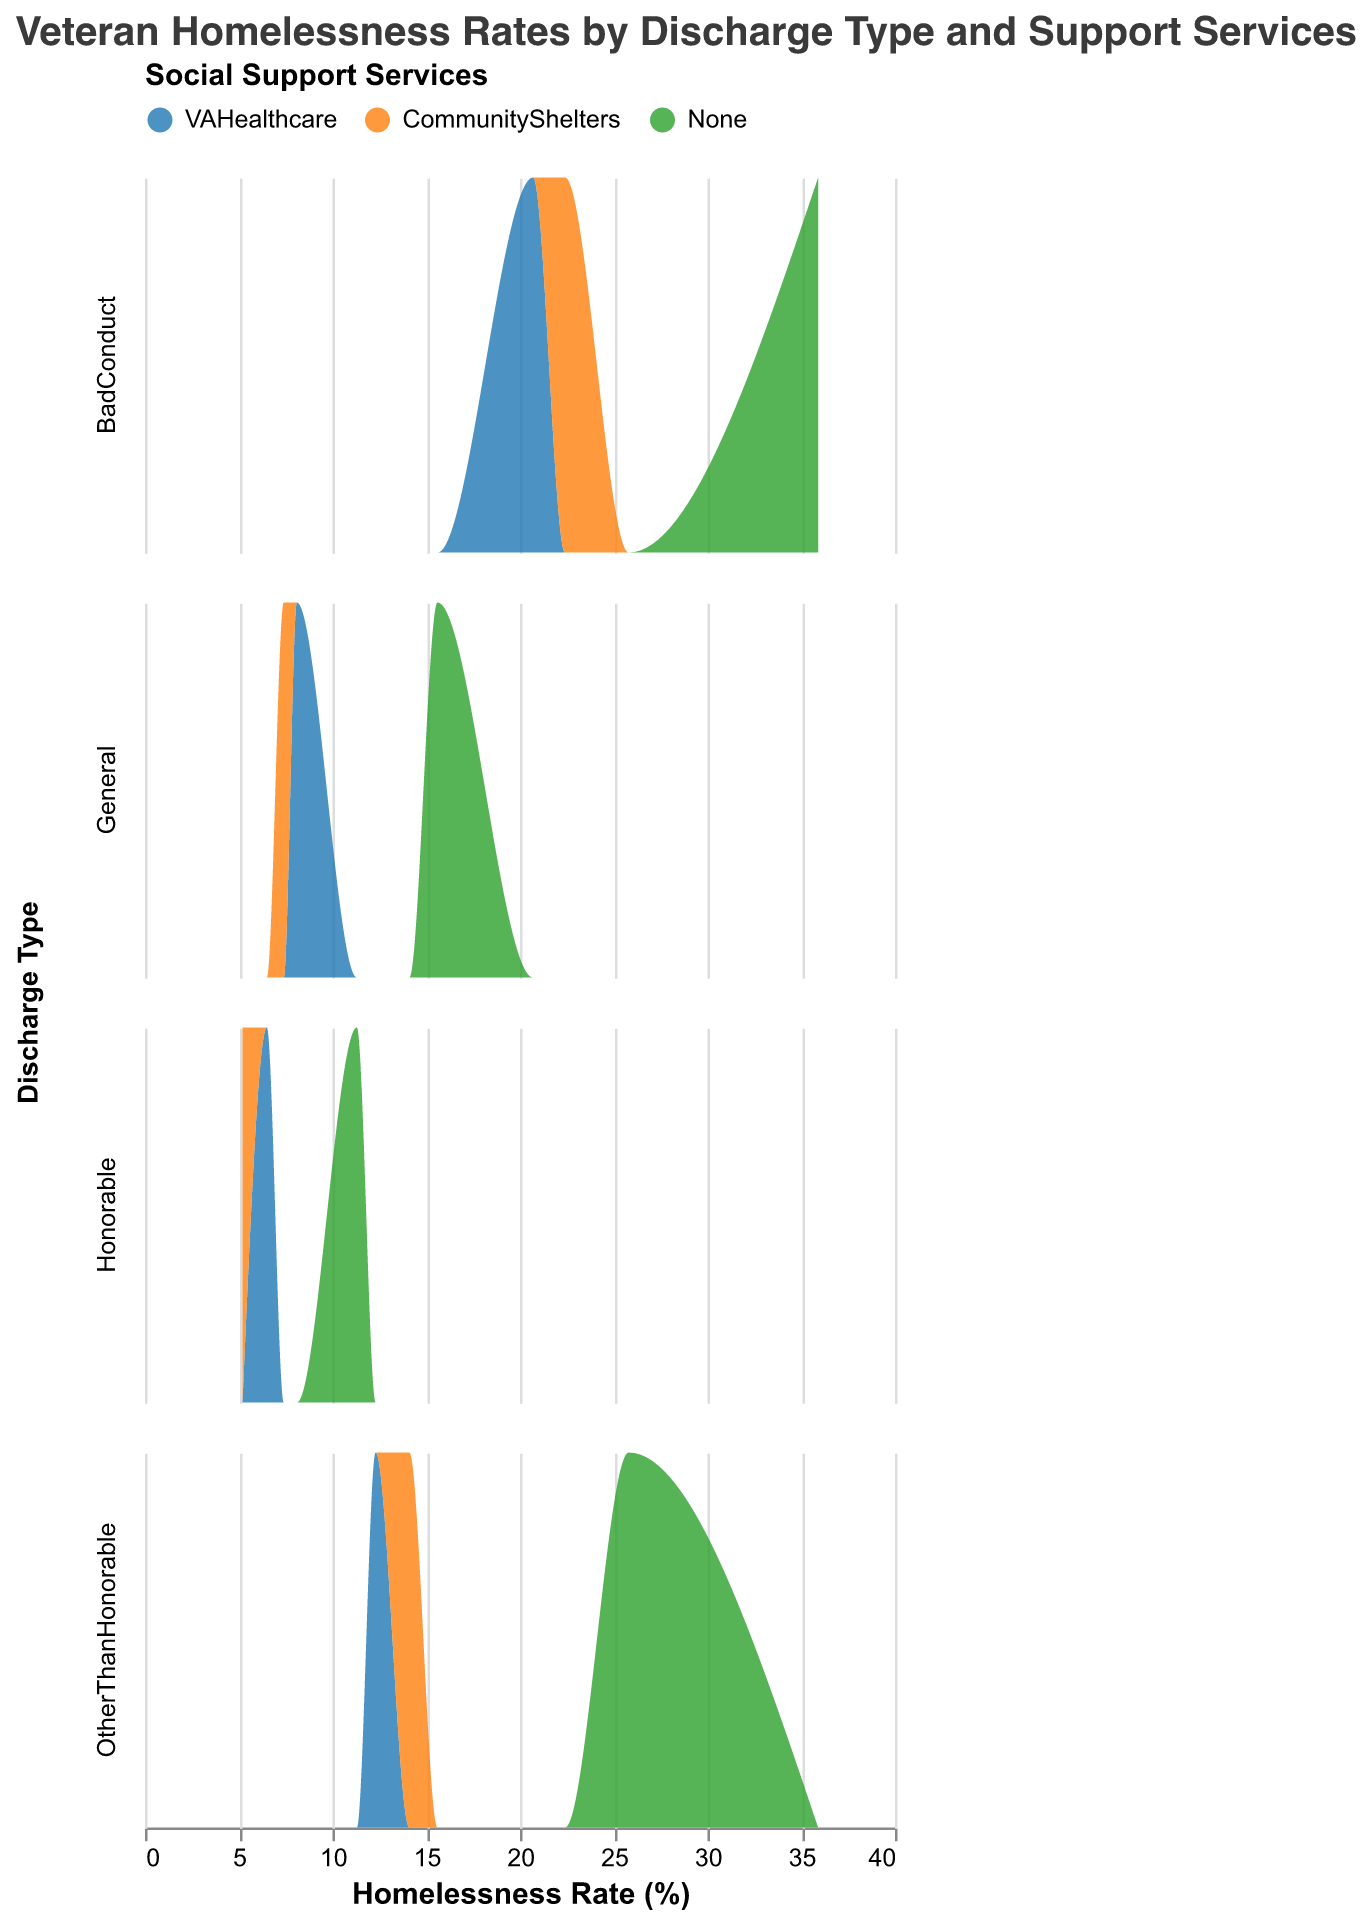What is the title of the figure? The title of a figure is typically located at the top and provides a brief description of the depicted data. In this case, it states the context and variables involved in the visualization of veteran homelessness rates.
Answer: "Veteran Homelessness Rates by Discharge Type and Support Services" What are the variables marked with different colors in the figure? Colors in the figure are used to differentiate between categories within a nominal variable. Here, different colors represent the types of social support services provided to veterans.
Answer: Social support services Which social support service generally appears to have the lowest homelessness rates across all discharge types? By observing the density plots and noting the positions of the different-colored peaks, we can determine which service typically corresponds to a lower range of homelessness rates. VAHealthcare appears to have peaks at generally lower homelessness rates compared to CommunityShelters and None.
Answer: VAHealthcare For veterans with a 'BadConduct' discharge type, which social support service is associated with the highest homelessness rate? By inspecting the density plot for 'BadConduct' discharge type, we should identify the color representing the highest homelessness rate in that subplot. The peak corresponding to 'None' reaches the highest value on the homelessness rate axis.
Answer: None How does the homelessness rate with 'None' support services for 'General' discharge compare to that of 'Honorable'? To answer this, we compare the highest homelessness rates for 'None' under 'General' and 'Honorable' discharge types. The homelessness rate for 'General' is 15.6% while for 'Honorable' it is 11.3%.
Answer: 'General' has a higher rate than 'Honorable' What is the range of homelessness rates for those with 'VAHealthcare' support services across all discharge types? Analyze where the peaks of the 'VAHealthcare' color line up on the homelessness rate axis across all subplots (discharge types). This observation gives a range of approximately 6.5% (Honorable) to 20.7% (BadConduct).
Answer: 6.5% to 20.7% Which discharge type has the highest observed homelessness rate and what is that rate? We must examine each subplot to find the highest peak of the density area. 'BadConduct' with 'None' support has the highest rate at 35.9%.
Answer: BadConduct, 35.9% By how much do homelessness rates rise when veterans with 'OtherThanHonorable' discharge switch from 'VAHealthcare' to 'None'? Compare the rate for 'VAHealthcare' (12.3%) to 'None' (25.8%) for the 'OtherThanHonorable' discharge type, then calculate the difference. The increase is 25.8% - 12.3% = 13.5%.
Answer: 13.5% Do veterans with 'Honorable' discharge and 'CommunityShelters' service have lower homelessness rates than those with 'General' discharge and 'VAHealthcare'? Compare the rates for 'Honorable' with 'CommunityShelters' (5.2%) to 'General' with 'VAHealthcare' (8.1%), noting that 5.2% is lower than 8.1%.
Answer: Yes 